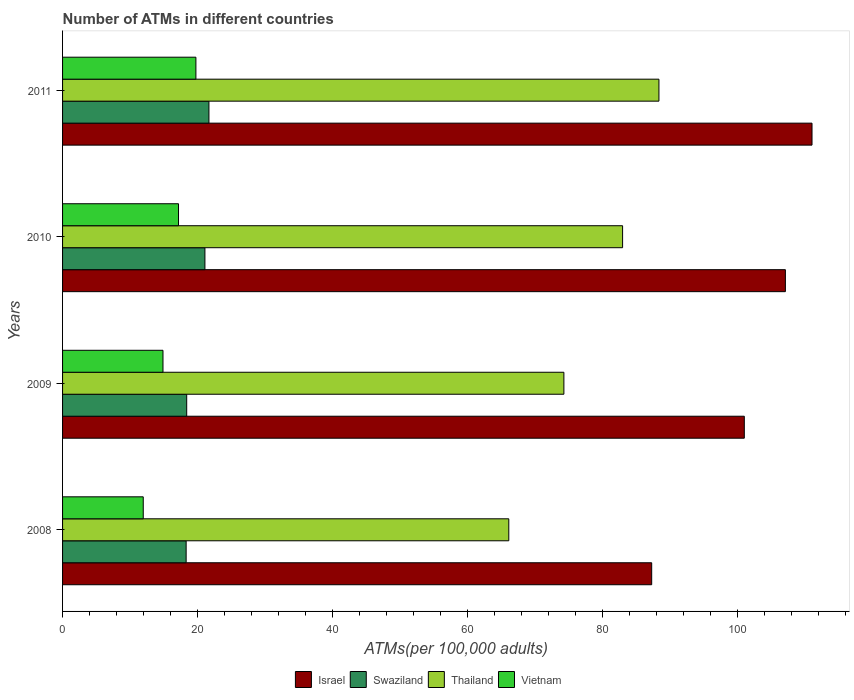How many groups of bars are there?
Offer a terse response. 4. Are the number of bars on each tick of the Y-axis equal?
Make the answer very short. Yes. How many bars are there on the 1st tick from the top?
Make the answer very short. 4. What is the number of ATMs in Israel in 2008?
Ensure brevity in your answer.  87.33. Across all years, what is the maximum number of ATMs in Thailand?
Offer a very short reply. 88.41. Across all years, what is the minimum number of ATMs in Swaziland?
Keep it short and to the point. 18.32. In which year was the number of ATMs in Swaziland maximum?
Ensure brevity in your answer.  2011. What is the total number of ATMs in Thailand in the graph?
Your answer should be compact. 311.9. What is the difference between the number of ATMs in Thailand in 2008 and that in 2010?
Offer a very short reply. -16.87. What is the difference between the number of ATMs in Thailand in 2010 and the number of ATMs in Vietnam in 2008?
Give a very brief answer. 71.06. What is the average number of ATMs in Israel per year?
Keep it short and to the point. 101.66. In the year 2011, what is the difference between the number of ATMs in Vietnam and number of ATMs in Israel?
Provide a succinct answer. -91.34. What is the ratio of the number of ATMs in Swaziland in 2008 to that in 2011?
Make the answer very short. 0.84. Is the number of ATMs in Thailand in 2010 less than that in 2011?
Your answer should be compact. Yes. Is the difference between the number of ATMs in Vietnam in 2008 and 2010 greater than the difference between the number of ATMs in Israel in 2008 and 2010?
Your answer should be compact. Yes. What is the difference between the highest and the second highest number of ATMs in Swaziland?
Offer a terse response. 0.6. What is the difference between the highest and the lowest number of ATMs in Swaziland?
Keep it short and to the point. 3.38. In how many years, is the number of ATMs in Swaziland greater than the average number of ATMs in Swaziland taken over all years?
Give a very brief answer. 2. What does the 3rd bar from the bottom in 2009 represents?
Offer a very short reply. Thailand. Are all the bars in the graph horizontal?
Make the answer very short. Yes. How many years are there in the graph?
Provide a short and direct response. 4. Are the values on the major ticks of X-axis written in scientific E-notation?
Your answer should be very brief. No. Does the graph contain any zero values?
Your answer should be very brief. No. How are the legend labels stacked?
Keep it short and to the point. Horizontal. What is the title of the graph?
Ensure brevity in your answer.  Number of ATMs in different countries. What is the label or title of the X-axis?
Your response must be concise. ATMs(per 100,0 adults). What is the label or title of the Y-axis?
Offer a terse response. Years. What is the ATMs(per 100,000 adults) in Israel in 2008?
Provide a short and direct response. 87.33. What is the ATMs(per 100,000 adults) of Swaziland in 2008?
Keep it short and to the point. 18.32. What is the ATMs(per 100,000 adults) of Thailand in 2008?
Your answer should be compact. 66.15. What is the ATMs(per 100,000 adults) in Vietnam in 2008?
Offer a very short reply. 11.96. What is the ATMs(per 100,000 adults) of Israel in 2009?
Offer a very short reply. 101.06. What is the ATMs(per 100,000 adults) in Swaziland in 2009?
Make the answer very short. 18.4. What is the ATMs(per 100,000 adults) of Thailand in 2009?
Provide a short and direct response. 74.32. What is the ATMs(per 100,000 adults) in Vietnam in 2009?
Give a very brief answer. 14.89. What is the ATMs(per 100,000 adults) in Israel in 2010?
Offer a very short reply. 107.16. What is the ATMs(per 100,000 adults) in Swaziland in 2010?
Provide a succinct answer. 21.1. What is the ATMs(per 100,000 adults) in Thailand in 2010?
Give a very brief answer. 83.02. What is the ATMs(per 100,000 adults) of Vietnam in 2010?
Give a very brief answer. 17.19. What is the ATMs(per 100,000 adults) in Israel in 2011?
Give a very brief answer. 111.1. What is the ATMs(per 100,000 adults) of Swaziland in 2011?
Offer a very short reply. 21.7. What is the ATMs(per 100,000 adults) of Thailand in 2011?
Your answer should be compact. 88.41. What is the ATMs(per 100,000 adults) of Vietnam in 2011?
Ensure brevity in your answer.  19.77. Across all years, what is the maximum ATMs(per 100,000 adults) of Israel?
Your answer should be compact. 111.1. Across all years, what is the maximum ATMs(per 100,000 adults) in Swaziland?
Your answer should be very brief. 21.7. Across all years, what is the maximum ATMs(per 100,000 adults) in Thailand?
Provide a succinct answer. 88.41. Across all years, what is the maximum ATMs(per 100,000 adults) of Vietnam?
Provide a succinct answer. 19.77. Across all years, what is the minimum ATMs(per 100,000 adults) in Israel?
Ensure brevity in your answer.  87.33. Across all years, what is the minimum ATMs(per 100,000 adults) of Swaziland?
Provide a succinct answer. 18.32. Across all years, what is the minimum ATMs(per 100,000 adults) of Thailand?
Your answer should be compact. 66.15. Across all years, what is the minimum ATMs(per 100,000 adults) in Vietnam?
Provide a succinct answer. 11.96. What is the total ATMs(per 100,000 adults) in Israel in the graph?
Give a very brief answer. 406.66. What is the total ATMs(per 100,000 adults) in Swaziland in the graph?
Provide a short and direct response. 79.53. What is the total ATMs(per 100,000 adults) of Thailand in the graph?
Your answer should be compact. 311.9. What is the total ATMs(per 100,000 adults) of Vietnam in the graph?
Offer a terse response. 63.8. What is the difference between the ATMs(per 100,000 adults) of Israel in 2008 and that in 2009?
Make the answer very short. -13.73. What is the difference between the ATMs(per 100,000 adults) in Swaziland in 2008 and that in 2009?
Provide a short and direct response. -0.08. What is the difference between the ATMs(per 100,000 adults) of Thailand in 2008 and that in 2009?
Ensure brevity in your answer.  -8.17. What is the difference between the ATMs(per 100,000 adults) in Vietnam in 2008 and that in 2009?
Keep it short and to the point. -2.92. What is the difference between the ATMs(per 100,000 adults) in Israel in 2008 and that in 2010?
Your answer should be compact. -19.82. What is the difference between the ATMs(per 100,000 adults) of Swaziland in 2008 and that in 2010?
Keep it short and to the point. -2.78. What is the difference between the ATMs(per 100,000 adults) in Thailand in 2008 and that in 2010?
Offer a terse response. -16.87. What is the difference between the ATMs(per 100,000 adults) in Vietnam in 2008 and that in 2010?
Your response must be concise. -5.23. What is the difference between the ATMs(per 100,000 adults) in Israel in 2008 and that in 2011?
Keep it short and to the point. -23.77. What is the difference between the ATMs(per 100,000 adults) in Swaziland in 2008 and that in 2011?
Provide a short and direct response. -3.38. What is the difference between the ATMs(per 100,000 adults) of Thailand in 2008 and that in 2011?
Your answer should be very brief. -22.26. What is the difference between the ATMs(per 100,000 adults) of Vietnam in 2008 and that in 2011?
Your answer should be compact. -7.8. What is the difference between the ATMs(per 100,000 adults) of Israel in 2009 and that in 2010?
Ensure brevity in your answer.  -6.09. What is the difference between the ATMs(per 100,000 adults) of Swaziland in 2009 and that in 2010?
Offer a very short reply. -2.7. What is the difference between the ATMs(per 100,000 adults) of Thailand in 2009 and that in 2010?
Offer a terse response. -8.7. What is the difference between the ATMs(per 100,000 adults) of Vietnam in 2009 and that in 2010?
Provide a short and direct response. -2.3. What is the difference between the ATMs(per 100,000 adults) in Israel in 2009 and that in 2011?
Offer a terse response. -10.04. What is the difference between the ATMs(per 100,000 adults) of Swaziland in 2009 and that in 2011?
Keep it short and to the point. -3.3. What is the difference between the ATMs(per 100,000 adults) in Thailand in 2009 and that in 2011?
Provide a short and direct response. -14.09. What is the difference between the ATMs(per 100,000 adults) in Vietnam in 2009 and that in 2011?
Keep it short and to the point. -4.88. What is the difference between the ATMs(per 100,000 adults) of Israel in 2010 and that in 2011?
Your answer should be very brief. -3.95. What is the difference between the ATMs(per 100,000 adults) of Swaziland in 2010 and that in 2011?
Your response must be concise. -0.6. What is the difference between the ATMs(per 100,000 adults) of Thailand in 2010 and that in 2011?
Keep it short and to the point. -5.39. What is the difference between the ATMs(per 100,000 adults) in Vietnam in 2010 and that in 2011?
Offer a terse response. -2.58. What is the difference between the ATMs(per 100,000 adults) of Israel in 2008 and the ATMs(per 100,000 adults) of Swaziland in 2009?
Give a very brief answer. 68.93. What is the difference between the ATMs(per 100,000 adults) of Israel in 2008 and the ATMs(per 100,000 adults) of Thailand in 2009?
Give a very brief answer. 13.02. What is the difference between the ATMs(per 100,000 adults) in Israel in 2008 and the ATMs(per 100,000 adults) in Vietnam in 2009?
Offer a very short reply. 72.45. What is the difference between the ATMs(per 100,000 adults) of Swaziland in 2008 and the ATMs(per 100,000 adults) of Thailand in 2009?
Your answer should be very brief. -56. What is the difference between the ATMs(per 100,000 adults) of Swaziland in 2008 and the ATMs(per 100,000 adults) of Vietnam in 2009?
Your answer should be very brief. 3.43. What is the difference between the ATMs(per 100,000 adults) of Thailand in 2008 and the ATMs(per 100,000 adults) of Vietnam in 2009?
Make the answer very short. 51.27. What is the difference between the ATMs(per 100,000 adults) of Israel in 2008 and the ATMs(per 100,000 adults) of Swaziland in 2010?
Keep it short and to the point. 66.23. What is the difference between the ATMs(per 100,000 adults) of Israel in 2008 and the ATMs(per 100,000 adults) of Thailand in 2010?
Keep it short and to the point. 4.31. What is the difference between the ATMs(per 100,000 adults) of Israel in 2008 and the ATMs(per 100,000 adults) of Vietnam in 2010?
Keep it short and to the point. 70.14. What is the difference between the ATMs(per 100,000 adults) of Swaziland in 2008 and the ATMs(per 100,000 adults) of Thailand in 2010?
Make the answer very short. -64.7. What is the difference between the ATMs(per 100,000 adults) of Swaziland in 2008 and the ATMs(per 100,000 adults) of Vietnam in 2010?
Offer a terse response. 1.13. What is the difference between the ATMs(per 100,000 adults) in Thailand in 2008 and the ATMs(per 100,000 adults) in Vietnam in 2010?
Make the answer very short. 48.96. What is the difference between the ATMs(per 100,000 adults) in Israel in 2008 and the ATMs(per 100,000 adults) in Swaziland in 2011?
Offer a terse response. 65.64. What is the difference between the ATMs(per 100,000 adults) in Israel in 2008 and the ATMs(per 100,000 adults) in Thailand in 2011?
Offer a very short reply. -1.07. What is the difference between the ATMs(per 100,000 adults) of Israel in 2008 and the ATMs(per 100,000 adults) of Vietnam in 2011?
Your response must be concise. 67.57. What is the difference between the ATMs(per 100,000 adults) in Swaziland in 2008 and the ATMs(per 100,000 adults) in Thailand in 2011?
Your answer should be compact. -70.09. What is the difference between the ATMs(per 100,000 adults) in Swaziland in 2008 and the ATMs(per 100,000 adults) in Vietnam in 2011?
Provide a short and direct response. -1.45. What is the difference between the ATMs(per 100,000 adults) in Thailand in 2008 and the ATMs(per 100,000 adults) in Vietnam in 2011?
Ensure brevity in your answer.  46.39. What is the difference between the ATMs(per 100,000 adults) of Israel in 2009 and the ATMs(per 100,000 adults) of Swaziland in 2010?
Your response must be concise. 79.96. What is the difference between the ATMs(per 100,000 adults) in Israel in 2009 and the ATMs(per 100,000 adults) in Thailand in 2010?
Provide a succinct answer. 18.04. What is the difference between the ATMs(per 100,000 adults) of Israel in 2009 and the ATMs(per 100,000 adults) of Vietnam in 2010?
Ensure brevity in your answer.  83.87. What is the difference between the ATMs(per 100,000 adults) in Swaziland in 2009 and the ATMs(per 100,000 adults) in Thailand in 2010?
Your response must be concise. -64.62. What is the difference between the ATMs(per 100,000 adults) in Swaziland in 2009 and the ATMs(per 100,000 adults) in Vietnam in 2010?
Make the answer very short. 1.21. What is the difference between the ATMs(per 100,000 adults) of Thailand in 2009 and the ATMs(per 100,000 adults) of Vietnam in 2010?
Offer a very short reply. 57.13. What is the difference between the ATMs(per 100,000 adults) of Israel in 2009 and the ATMs(per 100,000 adults) of Swaziland in 2011?
Your answer should be compact. 79.36. What is the difference between the ATMs(per 100,000 adults) in Israel in 2009 and the ATMs(per 100,000 adults) in Thailand in 2011?
Offer a very short reply. 12.66. What is the difference between the ATMs(per 100,000 adults) of Israel in 2009 and the ATMs(per 100,000 adults) of Vietnam in 2011?
Offer a very short reply. 81.3. What is the difference between the ATMs(per 100,000 adults) in Swaziland in 2009 and the ATMs(per 100,000 adults) in Thailand in 2011?
Keep it short and to the point. -70.01. What is the difference between the ATMs(per 100,000 adults) in Swaziland in 2009 and the ATMs(per 100,000 adults) in Vietnam in 2011?
Keep it short and to the point. -1.36. What is the difference between the ATMs(per 100,000 adults) of Thailand in 2009 and the ATMs(per 100,000 adults) of Vietnam in 2011?
Your answer should be very brief. 54.55. What is the difference between the ATMs(per 100,000 adults) of Israel in 2010 and the ATMs(per 100,000 adults) of Swaziland in 2011?
Provide a succinct answer. 85.46. What is the difference between the ATMs(per 100,000 adults) of Israel in 2010 and the ATMs(per 100,000 adults) of Thailand in 2011?
Your answer should be very brief. 18.75. What is the difference between the ATMs(per 100,000 adults) in Israel in 2010 and the ATMs(per 100,000 adults) in Vietnam in 2011?
Keep it short and to the point. 87.39. What is the difference between the ATMs(per 100,000 adults) in Swaziland in 2010 and the ATMs(per 100,000 adults) in Thailand in 2011?
Provide a short and direct response. -67.3. What is the difference between the ATMs(per 100,000 adults) in Swaziland in 2010 and the ATMs(per 100,000 adults) in Vietnam in 2011?
Keep it short and to the point. 1.34. What is the difference between the ATMs(per 100,000 adults) of Thailand in 2010 and the ATMs(per 100,000 adults) of Vietnam in 2011?
Make the answer very short. 63.25. What is the average ATMs(per 100,000 adults) in Israel per year?
Provide a succinct answer. 101.66. What is the average ATMs(per 100,000 adults) in Swaziland per year?
Your answer should be very brief. 19.88. What is the average ATMs(per 100,000 adults) of Thailand per year?
Make the answer very short. 77.97. What is the average ATMs(per 100,000 adults) of Vietnam per year?
Make the answer very short. 15.95. In the year 2008, what is the difference between the ATMs(per 100,000 adults) in Israel and ATMs(per 100,000 adults) in Swaziland?
Offer a very short reply. 69.01. In the year 2008, what is the difference between the ATMs(per 100,000 adults) of Israel and ATMs(per 100,000 adults) of Thailand?
Provide a succinct answer. 21.18. In the year 2008, what is the difference between the ATMs(per 100,000 adults) in Israel and ATMs(per 100,000 adults) in Vietnam?
Ensure brevity in your answer.  75.37. In the year 2008, what is the difference between the ATMs(per 100,000 adults) in Swaziland and ATMs(per 100,000 adults) in Thailand?
Provide a succinct answer. -47.83. In the year 2008, what is the difference between the ATMs(per 100,000 adults) of Swaziland and ATMs(per 100,000 adults) of Vietnam?
Ensure brevity in your answer.  6.36. In the year 2008, what is the difference between the ATMs(per 100,000 adults) of Thailand and ATMs(per 100,000 adults) of Vietnam?
Offer a terse response. 54.19. In the year 2009, what is the difference between the ATMs(per 100,000 adults) of Israel and ATMs(per 100,000 adults) of Swaziland?
Provide a short and direct response. 82.66. In the year 2009, what is the difference between the ATMs(per 100,000 adults) in Israel and ATMs(per 100,000 adults) in Thailand?
Make the answer very short. 26.75. In the year 2009, what is the difference between the ATMs(per 100,000 adults) in Israel and ATMs(per 100,000 adults) in Vietnam?
Keep it short and to the point. 86.18. In the year 2009, what is the difference between the ATMs(per 100,000 adults) in Swaziland and ATMs(per 100,000 adults) in Thailand?
Keep it short and to the point. -55.92. In the year 2009, what is the difference between the ATMs(per 100,000 adults) of Swaziland and ATMs(per 100,000 adults) of Vietnam?
Provide a short and direct response. 3.52. In the year 2009, what is the difference between the ATMs(per 100,000 adults) of Thailand and ATMs(per 100,000 adults) of Vietnam?
Ensure brevity in your answer.  59.43. In the year 2010, what is the difference between the ATMs(per 100,000 adults) of Israel and ATMs(per 100,000 adults) of Swaziland?
Make the answer very short. 86.05. In the year 2010, what is the difference between the ATMs(per 100,000 adults) of Israel and ATMs(per 100,000 adults) of Thailand?
Keep it short and to the point. 24.14. In the year 2010, what is the difference between the ATMs(per 100,000 adults) in Israel and ATMs(per 100,000 adults) in Vietnam?
Your response must be concise. 89.97. In the year 2010, what is the difference between the ATMs(per 100,000 adults) of Swaziland and ATMs(per 100,000 adults) of Thailand?
Make the answer very short. -61.92. In the year 2010, what is the difference between the ATMs(per 100,000 adults) of Swaziland and ATMs(per 100,000 adults) of Vietnam?
Your response must be concise. 3.91. In the year 2010, what is the difference between the ATMs(per 100,000 adults) of Thailand and ATMs(per 100,000 adults) of Vietnam?
Your response must be concise. 65.83. In the year 2011, what is the difference between the ATMs(per 100,000 adults) in Israel and ATMs(per 100,000 adults) in Swaziland?
Provide a short and direct response. 89.4. In the year 2011, what is the difference between the ATMs(per 100,000 adults) of Israel and ATMs(per 100,000 adults) of Thailand?
Offer a terse response. 22.69. In the year 2011, what is the difference between the ATMs(per 100,000 adults) of Israel and ATMs(per 100,000 adults) of Vietnam?
Offer a very short reply. 91.34. In the year 2011, what is the difference between the ATMs(per 100,000 adults) in Swaziland and ATMs(per 100,000 adults) in Thailand?
Offer a terse response. -66.71. In the year 2011, what is the difference between the ATMs(per 100,000 adults) of Swaziland and ATMs(per 100,000 adults) of Vietnam?
Keep it short and to the point. 1.93. In the year 2011, what is the difference between the ATMs(per 100,000 adults) in Thailand and ATMs(per 100,000 adults) in Vietnam?
Offer a terse response. 68.64. What is the ratio of the ATMs(per 100,000 adults) of Israel in 2008 to that in 2009?
Offer a very short reply. 0.86. What is the ratio of the ATMs(per 100,000 adults) of Thailand in 2008 to that in 2009?
Give a very brief answer. 0.89. What is the ratio of the ATMs(per 100,000 adults) of Vietnam in 2008 to that in 2009?
Provide a short and direct response. 0.8. What is the ratio of the ATMs(per 100,000 adults) of Israel in 2008 to that in 2010?
Provide a short and direct response. 0.81. What is the ratio of the ATMs(per 100,000 adults) in Swaziland in 2008 to that in 2010?
Provide a succinct answer. 0.87. What is the ratio of the ATMs(per 100,000 adults) in Thailand in 2008 to that in 2010?
Give a very brief answer. 0.8. What is the ratio of the ATMs(per 100,000 adults) in Vietnam in 2008 to that in 2010?
Offer a terse response. 0.7. What is the ratio of the ATMs(per 100,000 adults) in Israel in 2008 to that in 2011?
Keep it short and to the point. 0.79. What is the ratio of the ATMs(per 100,000 adults) in Swaziland in 2008 to that in 2011?
Give a very brief answer. 0.84. What is the ratio of the ATMs(per 100,000 adults) in Thailand in 2008 to that in 2011?
Provide a short and direct response. 0.75. What is the ratio of the ATMs(per 100,000 adults) in Vietnam in 2008 to that in 2011?
Provide a succinct answer. 0.61. What is the ratio of the ATMs(per 100,000 adults) in Israel in 2009 to that in 2010?
Keep it short and to the point. 0.94. What is the ratio of the ATMs(per 100,000 adults) in Swaziland in 2009 to that in 2010?
Provide a succinct answer. 0.87. What is the ratio of the ATMs(per 100,000 adults) of Thailand in 2009 to that in 2010?
Your answer should be compact. 0.9. What is the ratio of the ATMs(per 100,000 adults) in Vietnam in 2009 to that in 2010?
Your answer should be compact. 0.87. What is the ratio of the ATMs(per 100,000 adults) in Israel in 2009 to that in 2011?
Ensure brevity in your answer.  0.91. What is the ratio of the ATMs(per 100,000 adults) of Swaziland in 2009 to that in 2011?
Make the answer very short. 0.85. What is the ratio of the ATMs(per 100,000 adults) in Thailand in 2009 to that in 2011?
Offer a very short reply. 0.84. What is the ratio of the ATMs(per 100,000 adults) of Vietnam in 2009 to that in 2011?
Provide a short and direct response. 0.75. What is the ratio of the ATMs(per 100,000 adults) of Israel in 2010 to that in 2011?
Give a very brief answer. 0.96. What is the ratio of the ATMs(per 100,000 adults) of Swaziland in 2010 to that in 2011?
Give a very brief answer. 0.97. What is the ratio of the ATMs(per 100,000 adults) of Thailand in 2010 to that in 2011?
Keep it short and to the point. 0.94. What is the ratio of the ATMs(per 100,000 adults) in Vietnam in 2010 to that in 2011?
Your answer should be compact. 0.87. What is the difference between the highest and the second highest ATMs(per 100,000 adults) of Israel?
Ensure brevity in your answer.  3.95. What is the difference between the highest and the second highest ATMs(per 100,000 adults) of Swaziland?
Provide a short and direct response. 0.6. What is the difference between the highest and the second highest ATMs(per 100,000 adults) of Thailand?
Give a very brief answer. 5.39. What is the difference between the highest and the second highest ATMs(per 100,000 adults) of Vietnam?
Keep it short and to the point. 2.58. What is the difference between the highest and the lowest ATMs(per 100,000 adults) in Israel?
Provide a succinct answer. 23.77. What is the difference between the highest and the lowest ATMs(per 100,000 adults) in Swaziland?
Give a very brief answer. 3.38. What is the difference between the highest and the lowest ATMs(per 100,000 adults) of Thailand?
Ensure brevity in your answer.  22.26. What is the difference between the highest and the lowest ATMs(per 100,000 adults) in Vietnam?
Your response must be concise. 7.8. 